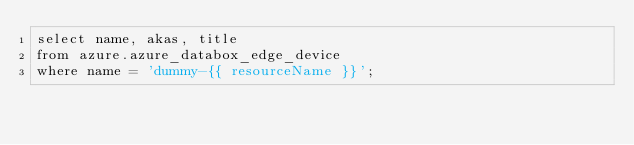<code> <loc_0><loc_0><loc_500><loc_500><_SQL_>select name, akas, title
from azure.azure_databox_edge_device
where name = 'dummy-{{ resourceName }}';
</code> 